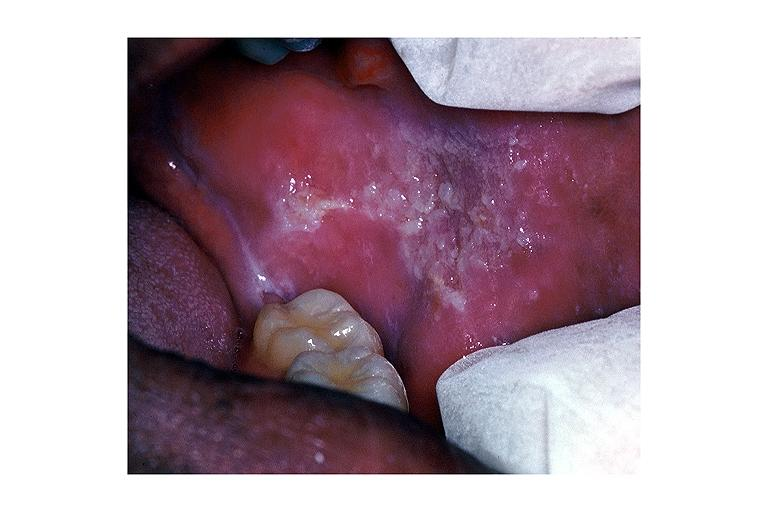s vasculature present?
Answer the question using a single word or phrase. No 